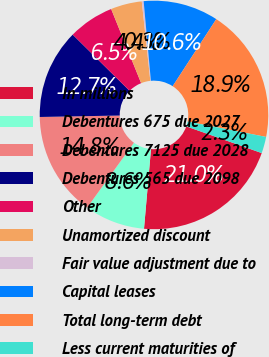Convert chart. <chart><loc_0><loc_0><loc_500><loc_500><pie_chart><fcel>In millions<fcel>Debentures 675 due 2027<fcel>Debentures 7125 due 2028<fcel>Debentures 565 due 2098<fcel>Other<fcel>Unamortized discount<fcel>Fair value adjustment due to<fcel>Capital leases<fcel>Total long-term debt<fcel>Less current maturities of<nl><fcel>20.98%<fcel>8.55%<fcel>14.77%<fcel>12.69%<fcel>6.48%<fcel>4.41%<fcel>0.26%<fcel>10.62%<fcel>18.91%<fcel>2.33%<nl></chart> 